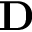Convert formula to latex. <formula><loc_0><loc_0><loc_500><loc_500>D</formula> 